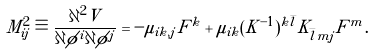Convert formula to latex. <formula><loc_0><loc_0><loc_500><loc_500>M ^ { 2 } _ { i j } \equiv \frac { \partial ^ { 2 } V } { \partial \phi ^ { i } \partial \phi ^ { j } } = - \mu _ { i k , j } F ^ { k } + \mu _ { i k } ( K ^ { - 1 } ) ^ { k \bar { l } } K _ { \bar { l } m j } F ^ { m } .</formula> 